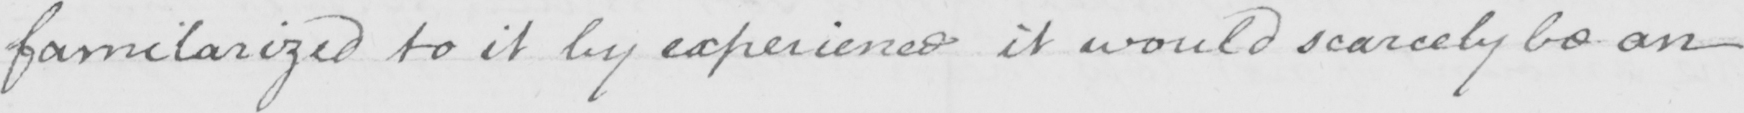Transcribe the text shown in this historical manuscript line. familarized to it by experience it would scarcely be an 